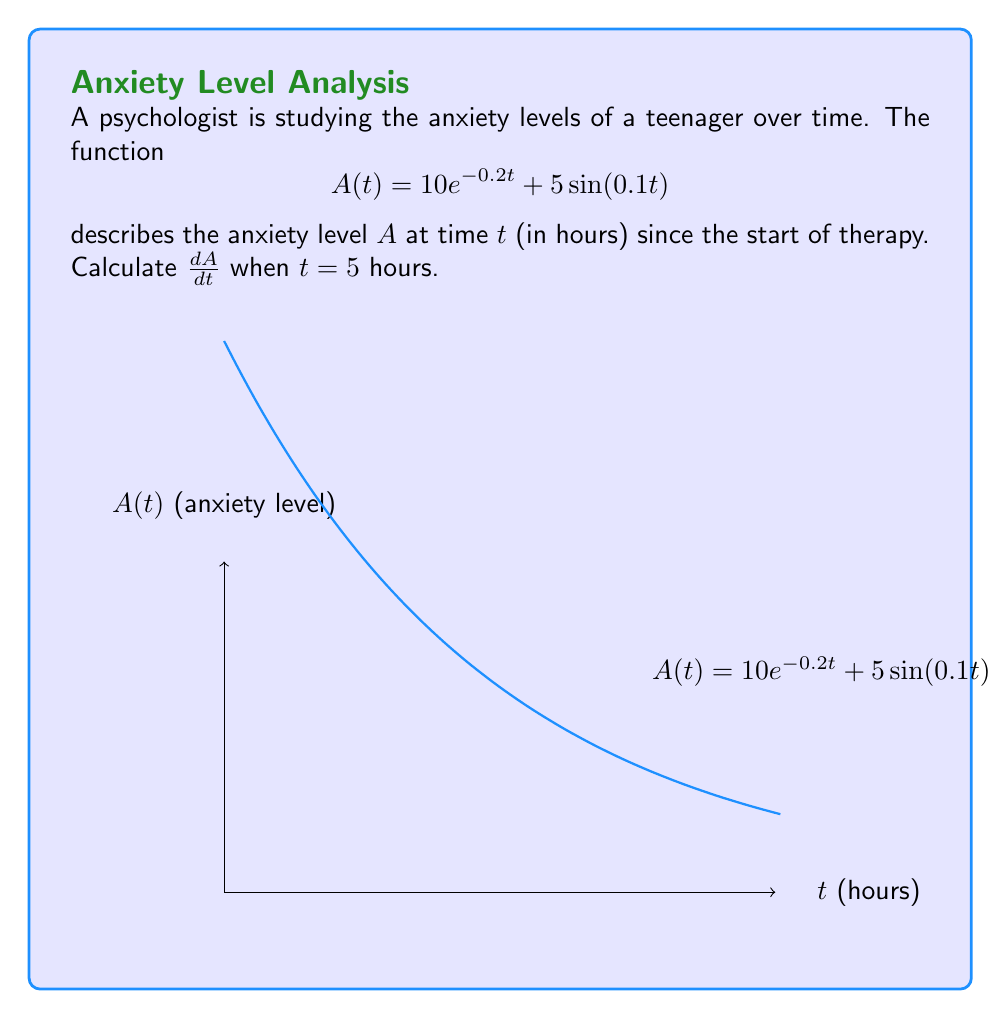Could you help me with this problem? To find $\frac{dA}{dt}$ when $t = 5$, we need to:

1) Find the general derivative of $A(t)$:
   $$\frac{d}{dt}[A(t)] = \frac{d}{dt}[10e^{-0.2t} + 5\sin(0.1t)]$$

2) Use the sum rule of derivatives:
   $$\frac{dA}{dt} = \frac{d}{dt}[10e^{-0.2t}] + \frac{d}{dt}[5\sin(0.1t)]$$

3) Apply the chain rule to both terms:
   $$\frac{dA}{dt} = 10 \cdot (-0.2) \cdot e^{-0.2t} + 5 \cdot 0.1 \cdot \cos(0.1t)$$

4) Simplify:
   $$\frac{dA}{dt} = -2e^{-0.2t} + 0.5\cos(0.1t)$$

5) Evaluate at $t = 5$:
   $$\frac{dA}{dt}\bigg|_{t=5} = -2e^{-0.2(5)} + 0.5\cos(0.1(5))$$

6) Calculate:
   $$\frac{dA}{dt}\bigg|_{t=5} = -2e^{-1} + 0.5\cos(0.5)$$
   $$\approx -0.7358 + 0.4387$$
   $$\approx -0.2971$$
Answer: $-0.2971$ 